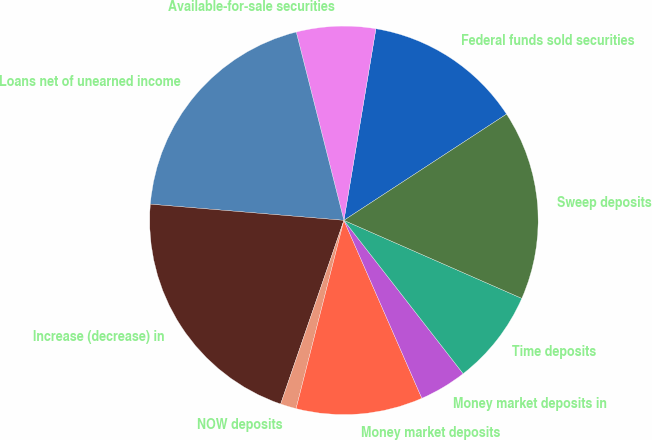<chart> <loc_0><loc_0><loc_500><loc_500><pie_chart><fcel>Federal funds sold securities<fcel>Available-for-sale securities<fcel>Loans net of unearned income<fcel>Increase (decrease) in<fcel>NOW deposits<fcel>Money market deposits<fcel>Money market deposits in<fcel>Time deposits<fcel>Sweep deposits<nl><fcel>13.16%<fcel>6.58%<fcel>19.73%<fcel>21.05%<fcel>1.32%<fcel>10.53%<fcel>3.95%<fcel>7.9%<fcel>15.79%<nl></chart> 